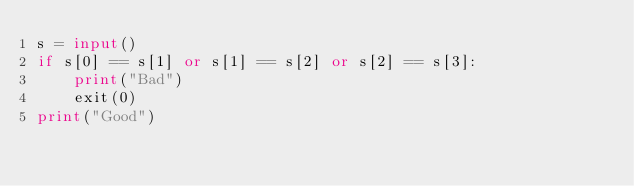Convert code to text. <code><loc_0><loc_0><loc_500><loc_500><_Python_>s = input()
if s[0] == s[1] or s[1] == s[2] or s[2] == s[3]:
    print("Bad")
    exit(0)
print("Good")</code> 